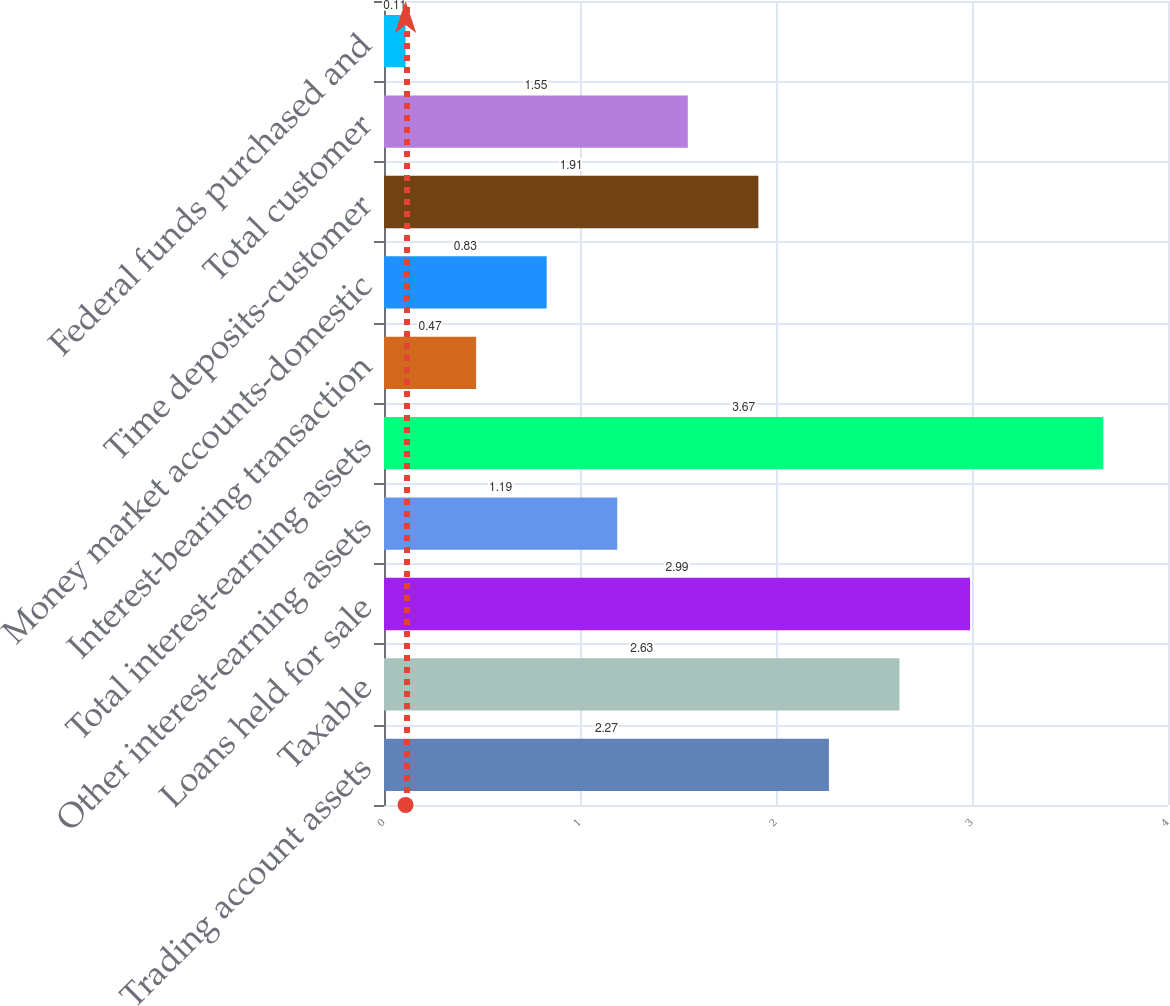<chart> <loc_0><loc_0><loc_500><loc_500><bar_chart><fcel>Trading account assets<fcel>Taxable<fcel>Loans held for sale<fcel>Other interest-earning assets<fcel>Total interest-earning assets<fcel>Interest-bearing transaction<fcel>Money market accounts-domestic<fcel>Time deposits-customer<fcel>Total customer<fcel>Federal funds purchased and<nl><fcel>2.27<fcel>2.63<fcel>2.99<fcel>1.19<fcel>3.67<fcel>0.47<fcel>0.83<fcel>1.91<fcel>1.55<fcel>0.11<nl></chart> 